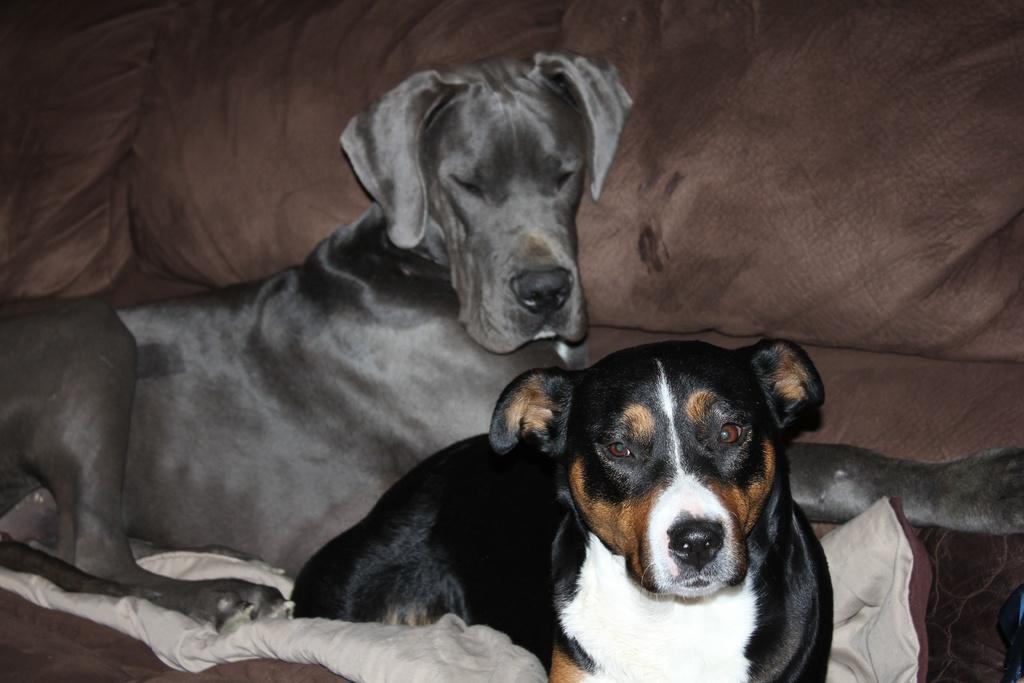In one or two sentences, can you explain what this image depicts? In this image there are two dogs sitting on a sofa. 